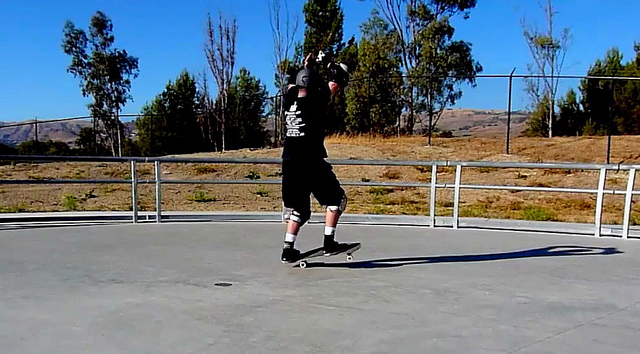What do you think the man is feeling while skateboarding in this setting? The man likely feels a sense of exhilaration and freedom while skateboarding in this open, scenic setting. Engaging in a physically demanding and skillful activity like skateboarding can induce a state of flow, where he is absorbed and fully immersed in the moment. The combination of performing tricks successfully, feeling the breeze, and enjoying the natural environment around him probably brings a mix of joy, satisfaction, and thrill. Describe a realistic scenario involving the man skateboarding in this setting on a regular weekday. On a typical weekday, the man might visit this skate park after school or work. It could be late afternoon, with the sun setting, casting a warm glow over the concrete. He arrives, greeting a few familiar faces of friends and other skaters. After putting on his protective gear, he spends a few minutes warming up with simple tricks. As he gets comfortable, he starts practicing more complex maneuvers, feeling the rush with each successful trick. Occasionally, he exchanges tips and tricks with fellow skaters, enjoying the camaraderie. The session ends with a relaxed ride around the park, taking in the scenic view and reflecting on his progress before heading home, feeling invigorated. 